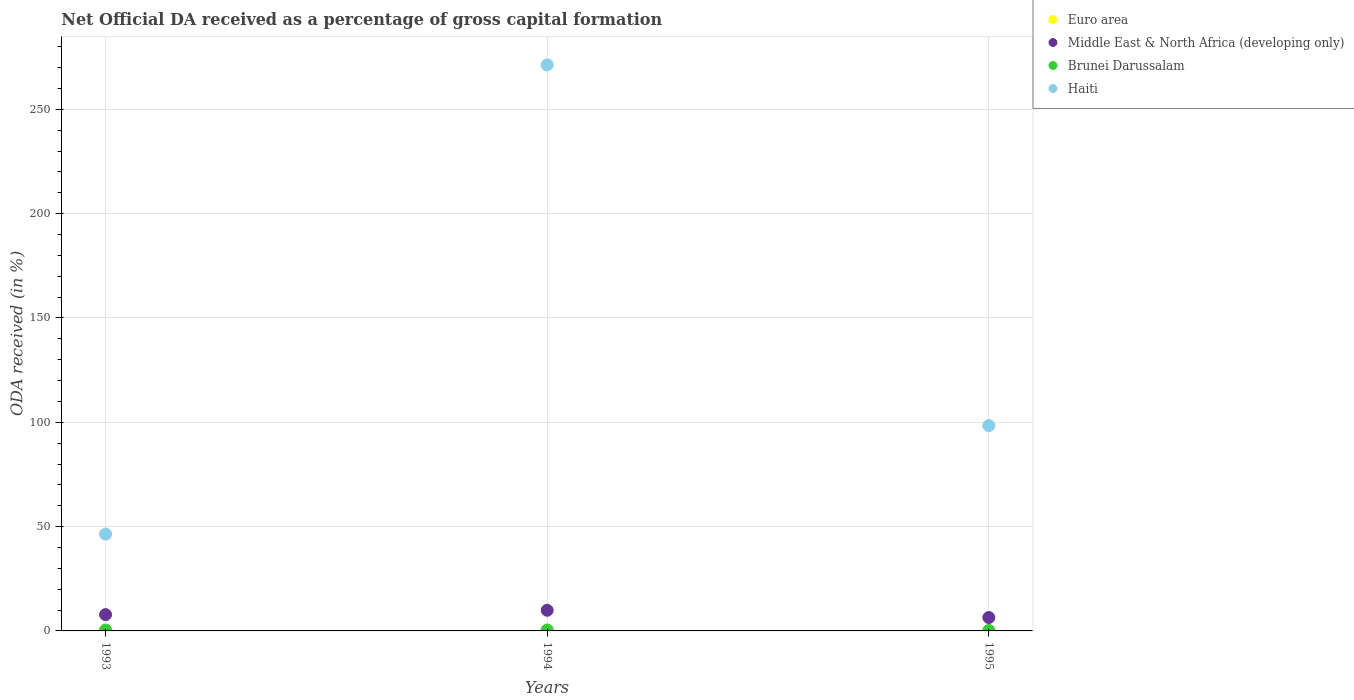How many different coloured dotlines are there?
Keep it short and to the point. 4. Is the number of dotlines equal to the number of legend labels?
Your answer should be compact. Yes. What is the net ODA received in Brunei Darussalam in 1994?
Provide a short and direct response. 0.45. Across all years, what is the maximum net ODA received in Brunei Darussalam?
Ensure brevity in your answer.  0.45. Across all years, what is the minimum net ODA received in Haiti?
Give a very brief answer. 46.42. In which year was the net ODA received in Brunei Darussalam maximum?
Make the answer very short. 1994. In which year was the net ODA received in Brunei Darussalam minimum?
Keep it short and to the point. 1995. What is the total net ODA received in Euro area in the graph?
Your answer should be compact. 0.02. What is the difference between the net ODA received in Euro area in 1993 and that in 1995?
Keep it short and to the point. 0. What is the difference between the net ODA received in Brunei Darussalam in 1993 and the net ODA received in Haiti in 1994?
Offer a very short reply. -270.88. What is the average net ODA received in Euro area per year?
Offer a very short reply. 0.01. In the year 1994, what is the difference between the net ODA received in Middle East & North Africa (developing only) and net ODA received in Brunei Darussalam?
Your response must be concise. 9.44. In how many years, is the net ODA received in Haiti greater than 40 %?
Provide a succinct answer. 3. What is the ratio of the net ODA received in Euro area in 1994 to that in 1995?
Your answer should be compact. 1.67. Is the net ODA received in Euro area in 1993 less than that in 1995?
Ensure brevity in your answer.  No. What is the difference between the highest and the second highest net ODA received in Brunei Darussalam?
Provide a succinct answer. 0.03. What is the difference between the highest and the lowest net ODA received in Brunei Darussalam?
Offer a very short reply. 0.2. In how many years, is the net ODA received in Haiti greater than the average net ODA received in Haiti taken over all years?
Make the answer very short. 1. Is the sum of the net ODA received in Euro area in 1994 and 1995 greater than the maximum net ODA received in Middle East & North Africa (developing only) across all years?
Your response must be concise. No. Is it the case that in every year, the sum of the net ODA received in Euro area and net ODA received in Haiti  is greater than the sum of net ODA received in Middle East & North Africa (developing only) and net ODA received in Brunei Darussalam?
Your answer should be very brief. Yes. Is it the case that in every year, the sum of the net ODA received in Middle East & North Africa (developing only) and net ODA received in Euro area  is greater than the net ODA received in Brunei Darussalam?
Offer a terse response. Yes. Is the net ODA received in Haiti strictly greater than the net ODA received in Euro area over the years?
Provide a succinct answer. Yes. Is the net ODA received in Haiti strictly less than the net ODA received in Brunei Darussalam over the years?
Your answer should be very brief. No. How many dotlines are there?
Ensure brevity in your answer.  4. What is the difference between two consecutive major ticks on the Y-axis?
Provide a short and direct response. 50. Does the graph contain any zero values?
Your answer should be compact. No. How are the legend labels stacked?
Give a very brief answer. Vertical. What is the title of the graph?
Provide a short and direct response. Net Official DA received as a percentage of gross capital formation. Does "Ukraine" appear as one of the legend labels in the graph?
Make the answer very short. No. What is the label or title of the Y-axis?
Your answer should be very brief. ODA received (in %). What is the ODA received (in %) of Euro area in 1993?
Make the answer very short. 0.01. What is the ODA received (in %) of Middle East & North Africa (developing only) in 1993?
Make the answer very short. 7.81. What is the ODA received (in %) in Brunei Darussalam in 1993?
Offer a very short reply. 0.42. What is the ODA received (in %) in Haiti in 1993?
Offer a terse response. 46.42. What is the ODA received (in %) of Euro area in 1994?
Your answer should be compact. 0.01. What is the ODA received (in %) in Middle East & North Africa (developing only) in 1994?
Your response must be concise. 9.89. What is the ODA received (in %) in Brunei Darussalam in 1994?
Offer a very short reply. 0.45. What is the ODA received (in %) in Haiti in 1994?
Offer a very short reply. 271.29. What is the ODA received (in %) in Euro area in 1995?
Offer a very short reply. 0.01. What is the ODA received (in %) in Middle East & North Africa (developing only) in 1995?
Offer a terse response. 6.42. What is the ODA received (in %) in Brunei Darussalam in 1995?
Provide a short and direct response. 0.25. What is the ODA received (in %) in Haiti in 1995?
Your response must be concise. 98.4. Across all years, what is the maximum ODA received (in %) of Euro area?
Provide a short and direct response. 0.01. Across all years, what is the maximum ODA received (in %) of Middle East & North Africa (developing only)?
Your answer should be compact. 9.89. Across all years, what is the maximum ODA received (in %) of Brunei Darussalam?
Provide a short and direct response. 0.45. Across all years, what is the maximum ODA received (in %) of Haiti?
Provide a short and direct response. 271.29. Across all years, what is the minimum ODA received (in %) of Euro area?
Keep it short and to the point. 0.01. Across all years, what is the minimum ODA received (in %) of Middle East & North Africa (developing only)?
Your answer should be compact. 6.42. Across all years, what is the minimum ODA received (in %) of Brunei Darussalam?
Provide a succinct answer. 0.25. Across all years, what is the minimum ODA received (in %) of Haiti?
Your response must be concise. 46.42. What is the total ODA received (in %) in Euro area in the graph?
Keep it short and to the point. 0.02. What is the total ODA received (in %) in Middle East & North Africa (developing only) in the graph?
Your response must be concise. 24.12. What is the total ODA received (in %) in Brunei Darussalam in the graph?
Provide a short and direct response. 1.11. What is the total ODA received (in %) in Haiti in the graph?
Give a very brief answer. 416.11. What is the difference between the ODA received (in %) of Euro area in 1993 and that in 1994?
Your answer should be very brief. -0. What is the difference between the ODA received (in %) in Middle East & North Africa (developing only) in 1993 and that in 1994?
Provide a short and direct response. -2.08. What is the difference between the ODA received (in %) of Brunei Darussalam in 1993 and that in 1994?
Offer a very short reply. -0.03. What is the difference between the ODA received (in %) in Haiti in 1993 and that in 1994?
Offer a terse response. -224.87. What is the difference between the ODA received (in %) of Euro area in 1993 and that in 1995?
Offer a terse response. 0. What is the difference between the ODA received (in %) in Middle East & North Africa (developing only) in 1993 and that in 1995?
Your answer should be very brief. 1.39. What is the difference between the ODA received (in %) of Brunei Darussalam in 1993 and that in 1995?
Give a very brief answer. 0.17. What is the difference between the ODA received (in %) in Haiti in 1993 and that in 1995?
Provide a succinct answer. -51.98. What is the difference between the ODA received (in %) in Euro area in 1994 and that in 1995?
Give a very brief answer. 0. What is the difference between the ODA received (in %) in Middle East & North Africa (developing only) in 1994 and that in 1995?
Make the answer very short. 3.46. What is the difference between the ODA received (in %) in Brunei Darussalam in 1994 and that in 1995?
Ensure brevity in your answer.  0.2. What is the difference between the ODA received (in %) in Haiti in 1994 and that in 1995?
Ensure brevity in your answer.  172.9. What is the difference between the ODA received (in %) of Euro area in 1993 and the ODA received (in %) of Middle East & North Africa (developing only) in 1994?
Provide a short and direct response. -9.88. What is the difference between the ODA received (in %) in Euro area in 1993 and the ODA received (in %) in Brunei Darussalam in 1994?
Ensure brevity in your answer.  -0.44. What is the difference between the ODA received (in %) of Euro area in 1993 and the ODA received (in %) of Haiti in 1994?
Offer a terse response. -271.29. What is the difference between the ODA received (in %) of Middle East & North Africa (developing only) in 1993 and the ODA received (in %) of Brunei Darussalam in 1994?
Your answer should be very brief. 7.36. What is the difference between the ODA received (in %) of Middle East & North Africa (developing only) in 1993 and the ODA received (in %) of Haiti in 1994?
Provide a succinct answer. -263.48. What is the difference between the ODA received (in %) of Brunei Darussalam in 1993 and the ODA received (in %) of Haiti in 1994?
Your answer should be compact. -270.88. What is the difference between the ODA received (in %) of Euro area in 1993 and the ODA received (in %) of Middle East & North Africa (developing only) in 1995?
Your answer should be very brief. -6.42. What is the difference between the ODA received (in %) in Euro area in 1993 and the ODA received (in %) in Brunei Darussalam in 1995?
Offer a very short reply. -0.24. What is the difference between the ODA received (in %) of Euro area in 1993 and the ODA received (in %) of Haiti in 1995?
Your response must be concise. -98.39. What is the difference between the ODA received (in %) in Middle East & North Africa (developing only) in 1993 and the ODA received (in %) in Brunei Darussalam in 1995?
Make the answer very short. 7.56. What is the difference between the ODA received (in %) of Middle East & North Africa (developing only) in 1993 and the ODA received (in %) of Haiti in 1995?
Ensure brevity in your answer.  -90.59. What is the difference between the ODA received (in %) in Brunei Darussalam in 1993 and the ODA received (in %) in Haiti in 1995?
Your response must be concise. -97.98. What is the difference between the ODA received (in %) of Euro area in 1994 and the ODA received (in %) of Middle East & North Africa (developing only) in 1995?
Make the answer very short. -6.42. What is the difference between the ODA received (in %) in Euro area in 1994 and the ODA received (in %) in Brunei Darussalam in 1995?
Your response must be concise. -0.24. What is the difference between the ODA received (in %) of Euro area in 1994 and the ODA received (in %) of Haiti in 1995?
Offer a terse response. -98.39. What is the difference between the ODA received (in %) of Middle East & North Africa (developing only) in 1994 and the ODA received (in %) of Brunei Darussalam in 1995?
Give a very brief answer. 9.64. What is the difference between the ODA received (in %) of Middle East & North Africa (developing only) in 1994 and the ODA received (in %) of Haiti in 1995?
Make the answer very short. -88.51. What is the difference between the ODA received (in %) of Brunei Darussalam in 1994 and the ODA received (in %) of Haiti in 1995?
Offer a very short reply. -97.95. What is the average ODA received (in %) in Euro area per year?
Provide a short and direct response. 0.01. What is the average ODA received (in %) in Middle East & North Africa (developing only) per year?
Give a very brief answer. 8.04. What is the average ODA received (in %) in Brunei Darussalam per year?
Your response must be concise. 0.37. What is the average ODA received (in %) of Haiti per year?
Provide a succinct answer. 138.7. In the year 1993, what is the difference between the ODA received (in %) in Euro area and ODA received (in %) in Middle East & North Africa (developing only)?
Your answer should be compact. -7.8. In the year 1993, what is the difference between the ODA received (in %) of Euro area and ODA received (in %) of Brunei Darussalam?
Your answer should be very brief. -0.41. In the year 1993, what is the difference between the ODA received (in %) of Euro area and ODA received (in %) of Haiti?
Offer a terse response. -46.42. In the year 1993, what is the difference between the ODA received (in %) in Middle East & North Africa (developing only) and ODA received (in %) in Brunei Darussalam?
Keep it short and to the point. 7.39. In the year 1993, what is the difference between the ODA received (in %) in Middle East & North Africa (developing only) and ODA received (in %) in Haiti?
Offer a very short reply. -38.61. In the year 1993, what is the difference between the ODA received (in %) in Brunei Darussalam and ODA received (in %) in Haiti?
Provide a succinct answer. -46.01. In the year 1994, what is the difference between the ODA received (in %) of Euro area and ODA received (in %) of Middle East & North Africa (developing only)?
Ensure brevity in your answer.  -9.88. In the year 1994, what is the difference between the ODA received (in %) of Euro area and ODA received (in %) of Brunei Darussalam?
Your answer should be compact. -0.44. In the year 1994, what is the difference between the ODA received (in %) of Euro area and ODA received (in %) of Haiti?
Provide a succinct answer. -271.28. In the year 1994, what is the difference between the ODA received (in %) in Middle East & North Africa (developing only) and ODA received (in %) in Brunei Darussalam?
Provide a short and direct response. 9.44. In the year 1994, what is the difference between the ODA received (in %) of Middle East & North Africa (developing only) and ODA received (in %) of Haiti?
Your answer should be very brief. -261.41. In the year 1994, what is the difference between the ODA received (in %) of Brunei Darussalam and ODA received (in %) of Haiti?
Give a very brief answer. -270.84. In the year 1995, what is the difference between the ODA received (in %) in Euro area and ODA received (in %) in Middle East & North Africa (developing only)?
Provide a succinct answer. -6.42. In the year 1995, what is the difference between the ODA received (in %) in Euro area and ODA received (in %) in Brunei Darussalam?
Your response must be concise. -0.24. In the year 1995, what is the difference between the ODA received (in %) of Euro area and ODA received (in %) of Haiti?
Your response must be concise. -98.39. In the year 1995, what is the difference between the ODA received (in %) in Middle East & North Africa (developing only) and ODA received (in %) in Brunei Darussalam?
Ensure brevity in your answer.  6.18. In the year 1995, what is the difference between the ODA received (in %) in Middle East & North Africa (developing only) and ODA received (in %) in Haiti?
Provide a succinct answer. -91.97. In the year 1995, what is the difference between the ODA received (in %) in Brunei Darussalam and ODA received (in %) in Haiti?
Your response must be concise. -98.15. What is the ratio of the ODA received (in %) in Euro area in 1993 to that in 1994?
Offer a terse response. 0.65. What is the ratio of the ODA received (in %) of Middle East & North Africa (developing only) in 1993 to that in 1994?
Give a very brief answer. 0.79. What is the ratio of the ODA received (in %) of Brunei Darussalam in 1993 to that in 1994?
Provide a succinct answer. 0.93. What is the ratio of the ODA received (in %) in Haiti in 1993 to that in 1994?
Your answer should be compact. 0.17. What is the ratio of the ODA received (in %) of Euro area in 1993 to that in 1995?
Keep it short and to the point. 1.09. What is the ratio of the ODA received (in %) of Middle East & North Africa (developing only) in 1993 to that in 1995?
Your response must be concise. 1.22. What is the ratio of the ODA received (in %) in Brunei Darussalam in 1993 to that in 1995?
Your answer should be very brief. 1.68. What is the ratio of the ODA received (in %) in Haiti in 1993 to that in 1995?
Your response must be concise. 0.47. What is the ratio of the ODA received (in %) of Euro area in 1994 to that in 1995?
Keep it short and to the point. 1.67. What is the ratio of the ODA received (in %) in Middle East & North Africa (developing only) in 1994 to that in 1995?
Give a very brief answer. 1.54. What is the ratio of the ODA received (in %) in Brunei Darussalam in 1994 to that in 1995?
Keep it short and to the point. 1.82. What is the ratio of the ODA received (in %) in Haiti in 1994 to that in 1995?
Offer a terse response. 2.76. What is the difference between the highest and the second highest ODA received (in %) in Euro area?
Offer a very short reply. 0. What is the difference between the highest and the second highest ODA received (in %) of Middle East & North Africa (developing only)?
Provide a short and direct response. 2.08. What is the difference between the highest and the second highest ODA received (in %) in Brunei Darussalam?
Provide a short and direct response. 0.03. What is the difference between the highest and the second highest ODA received (in %) in Haiti?
Make the answer very short. 172.9. What is the difference between the highest and the lowest ODA received (in %) of Euro area?
Your response must be concise. 0. What is the difference between the highest and the lowest ODA received (in %) in Middle East & North Africa (developing only)?
Offer a very short reply. 3.46. What is the difference between the highest and the lowest ODA received (in %) in Brunei Darussalam?
Provide a short and direct response. 0.2. What is the difference between the highest and the lowest ODA received (in %) of Haiti?
Offer a terse response. 224.87. 